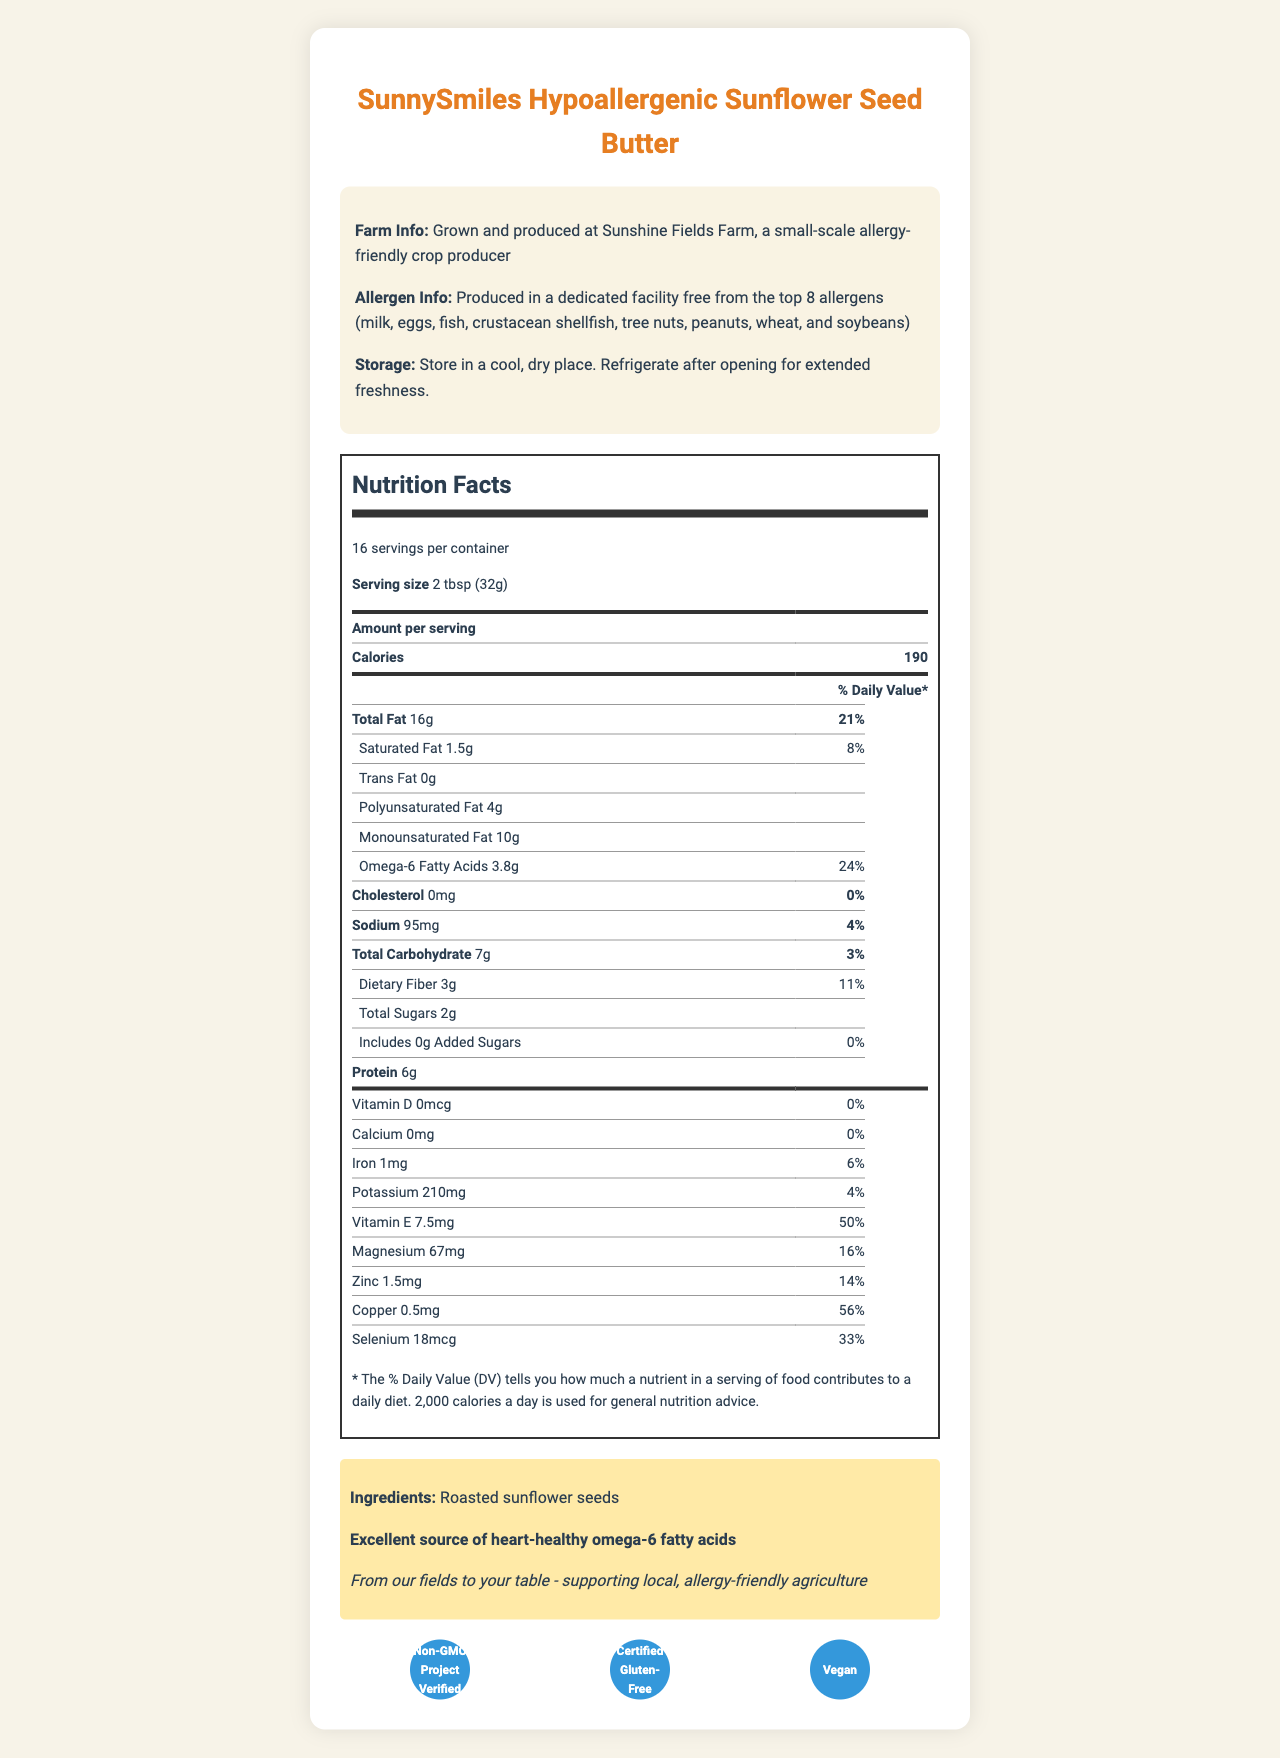what is the serving size of SunnySmiles Hypoallergenic Sunflower Seed Butter? The serving size is clearly stated under the nutrition facts label as 2 tbsp (32g).
Answer: 2 tbsp (32g) how many servings are there per container? The label mentions there are 16 servings per container.
Answer: 16 how many calories are in each serving? The number of calories per serving is listed as 190.
Answer: 190 what is the amount of omega-6 fatty acids per serving? The amount of omega-6 fatty acids per serving is provided as 3.8g.
Answer: 3.8g how much dietary fiber is found in one serving? The dietary fiber content per serving is mentioned as 3g.
Answer: 3g which of the following certifications does the product have? A. USDA Organic B. Non-GMO Project Verified C. Certified Gluten-Free D. Vegan The document lists the following certifications: Non-GMO Project Verified, Certified Gluten-Free, and Vegan.
Answer: B, C, and D what percentage of the daily value of magnesium is provided per serving? A. 10% B. 16% C. 20% D. 25% The daily value for magnesium per serving is listed as 16%.
Answer: B is the product free from the top 8 allergens? According to the allergen information, the product is produced in a facility free from the top 8 allergens.
Answer: Yes summarize the main point of the SunnySmiles Hypoallergenic Sunflower Seed Butter document. The summary covers critical details such as nutrition information, hypoallergenic properties, and certifications.
Answer: The document provides comprehensive information on SunnySmiles Hypoallergenic Sunflower Seed Butter, including nutrition facts, serving size, number of servings per container, and health properties. It highlights the product's high omega-6 fatty acid content, how it is hypoallergenic, and made in a facility free from the top 8 allergens. It also mentions certifications like Non-GMO Project Verified, Certified Gluten-Free, and Vegan. how many grams of protein are in a serving? The amount of protein per serving is listed as 6g.
Answer: 6g can you determine if the product is organic from the document? The document does not provide information regarding whether the product is organic.
Answer: Cannot be determined how much saturated fat is in one serving? The document lists the saturated fat content per serving as 1.5g.
Answer: 1.5g 